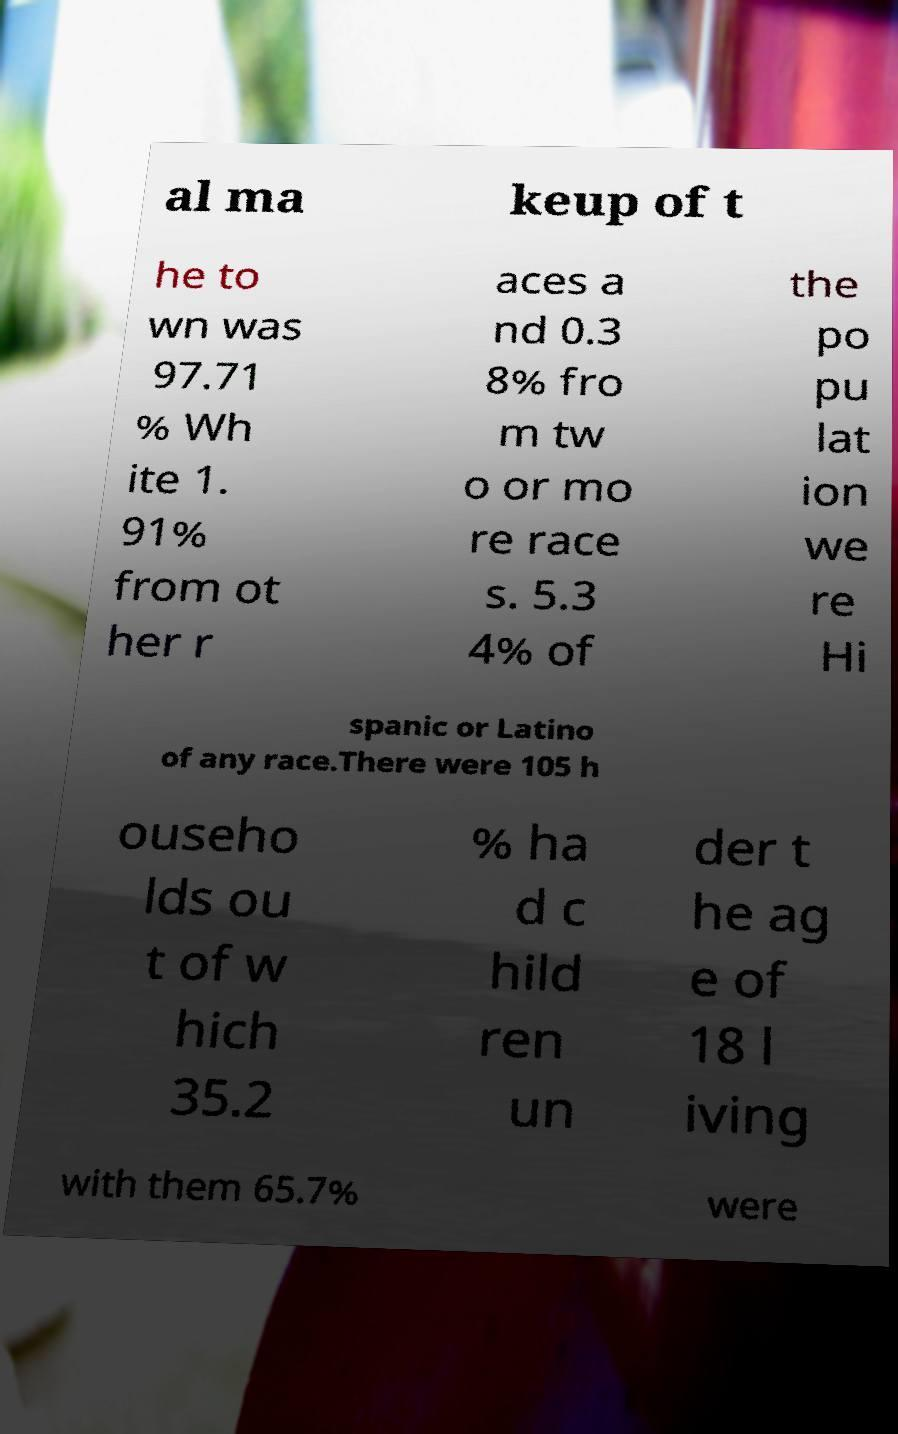Could you assist in decoding the text presented in this image and type it out clearly? al ma keup of t he to wn was 97.71 % Wh ite 1. 91% from ot her r aces a nd 0.3 8% fro m tw o or mo re race s. 5.3 4% of the po pu lat ion we re Hi spanic or Latino of any race.There were 105 h ouseho lds ou t of w hich 35.2 % ha d c hild ren un der t he ag e of 18 l iving with them 65.7% were 